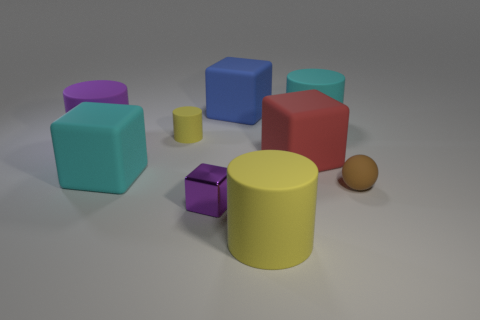Subtract all green blocks. How many yellow cylinders are left? 2 Subtract all small yellow cylinders. How many cylinders are left? 3 Add 1 tiny brown shiny cylinders. How many objects exist? 10 Subtract all yellow cubes. Subtract all green spheres. How many cubes are left? 4 Subtract all cylinders. How many objects are left? 5 Subtract all red balls. Subtract all large cyan cylinders. How many objects are left? 8 Add 2 large yellow objects. How many large yellow objects are left? 3 Add 9 tiny matte cylinders. How many tiny matte cylinders exist? 10 Subtract 0 green cylinders. How many objects are left? 9 